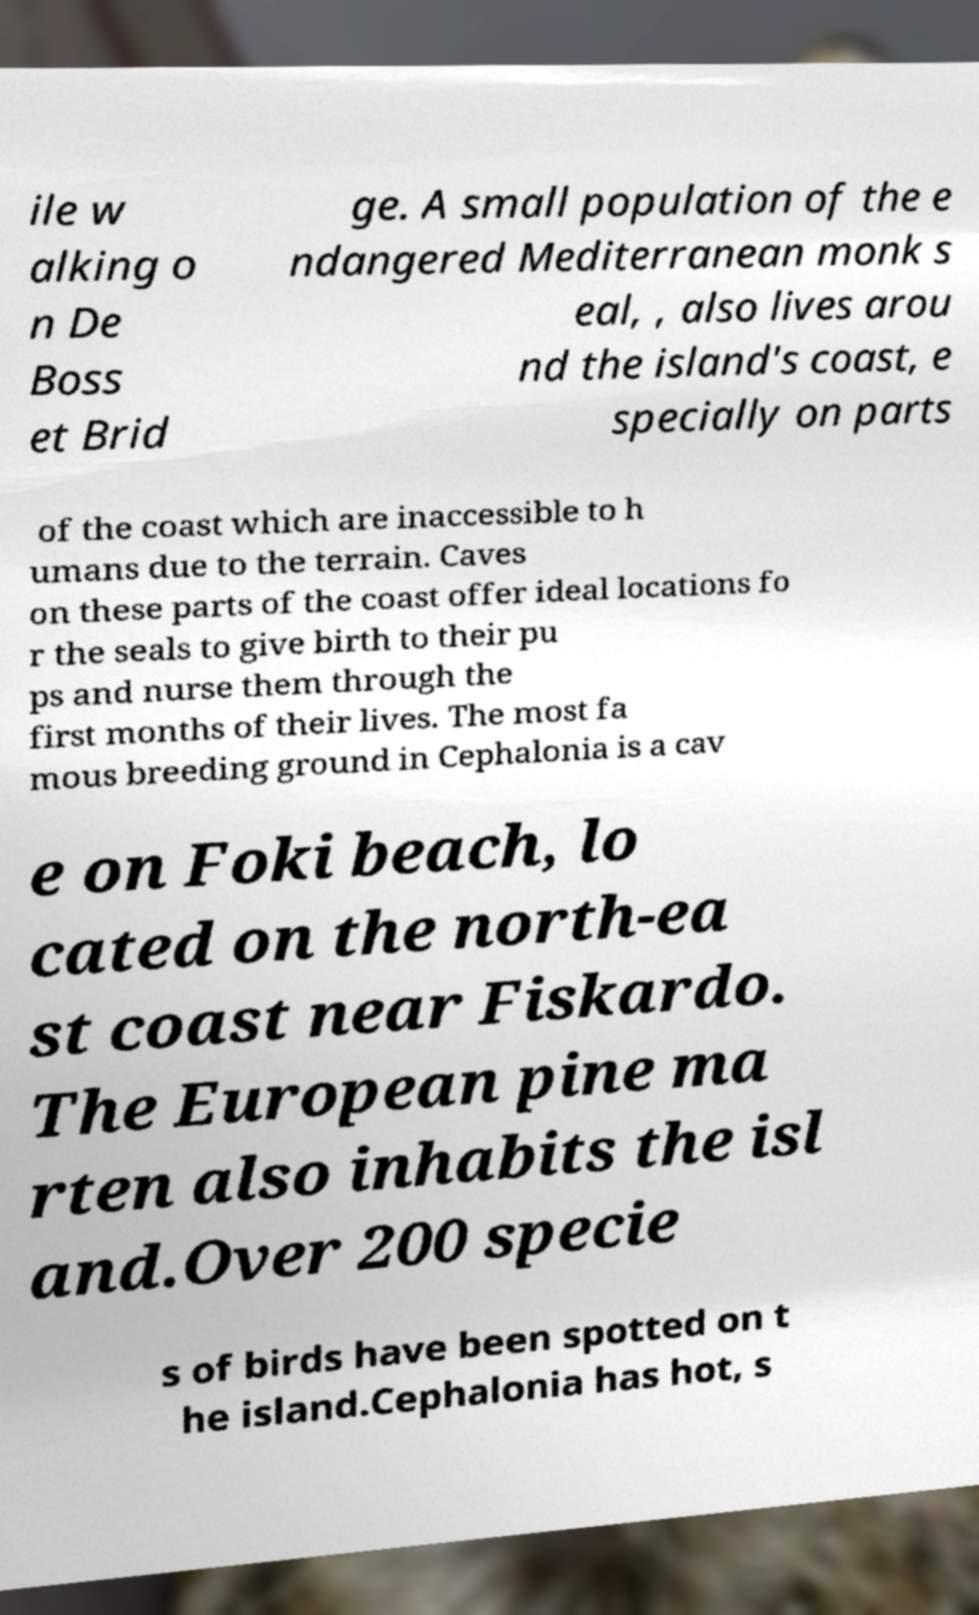Can you read and provide the text displayed in the image?This photo seems to have some interesting text. Can you extract and type it out for me? ile w alking o n De Boss et Brid ge. A small population of the e ndangered Mediterranean monk s eal, , also lives arou nd the island's coast, e specially on parts of the coast which are inaccessible to h umans due to the terrain. Caves on these parts of the coast offer ideal locations fo r the seals to give birth to their pu ps and nurse them through the first months of their lives. The most fa mous breeding ground in Cephalonia is a cav e on Foki beach, lo cated on the north-ea st coast near Fiskardo. The European pine ma rten also inhabits the isl and.Over 200 specie s of birds have been spotted on t he island.Cephalonia has hot, s 